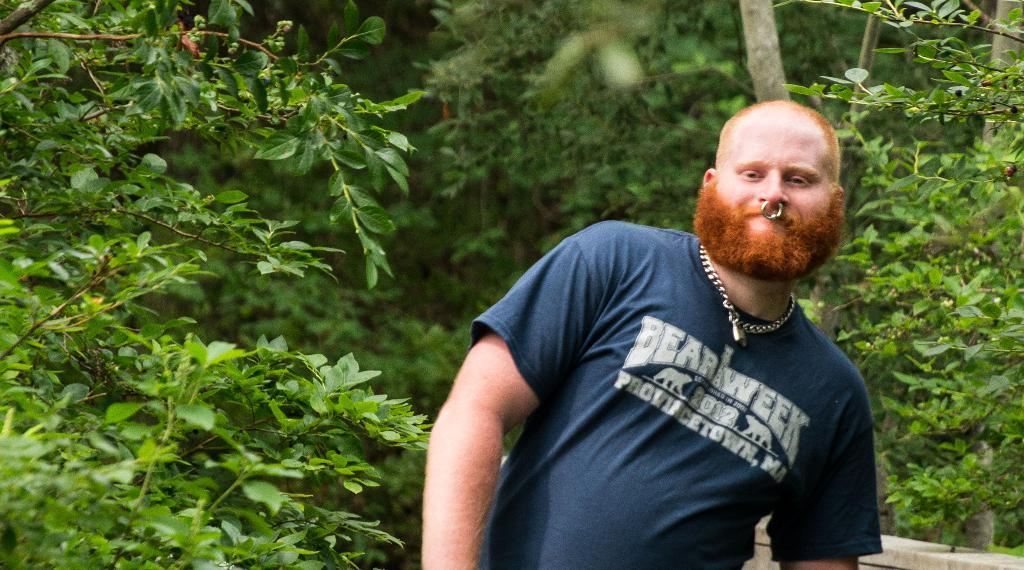Who is in the image? There is a man in the image. What is the man wearing? The man is wearing a blue T-shirt. What is the man doing in the image? The man is standing. What is beside the man in the image? There is a wall beside the man. What can be seen in the background of the image? There are trees in the background of the image. Where might this image have been taken? The image might have been taken in a park, given the presence of trees in the background. What can the man hear in the image? The image does not provide any information about sounds or what the man might be hearing. 